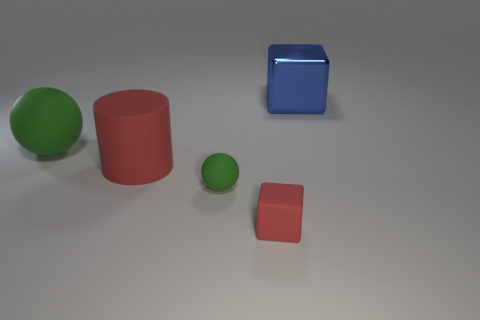Can you tell which object is the largest and by what aspect? The green sphere on the left is the largest by volume and surface area, with its diameter exceeding the length of any edge on the cubes. Does the lighting suggest anything about the positioning of the light source? Yes, the shadows cast by the objects indicate that the light source is to the upper right of the scene. 